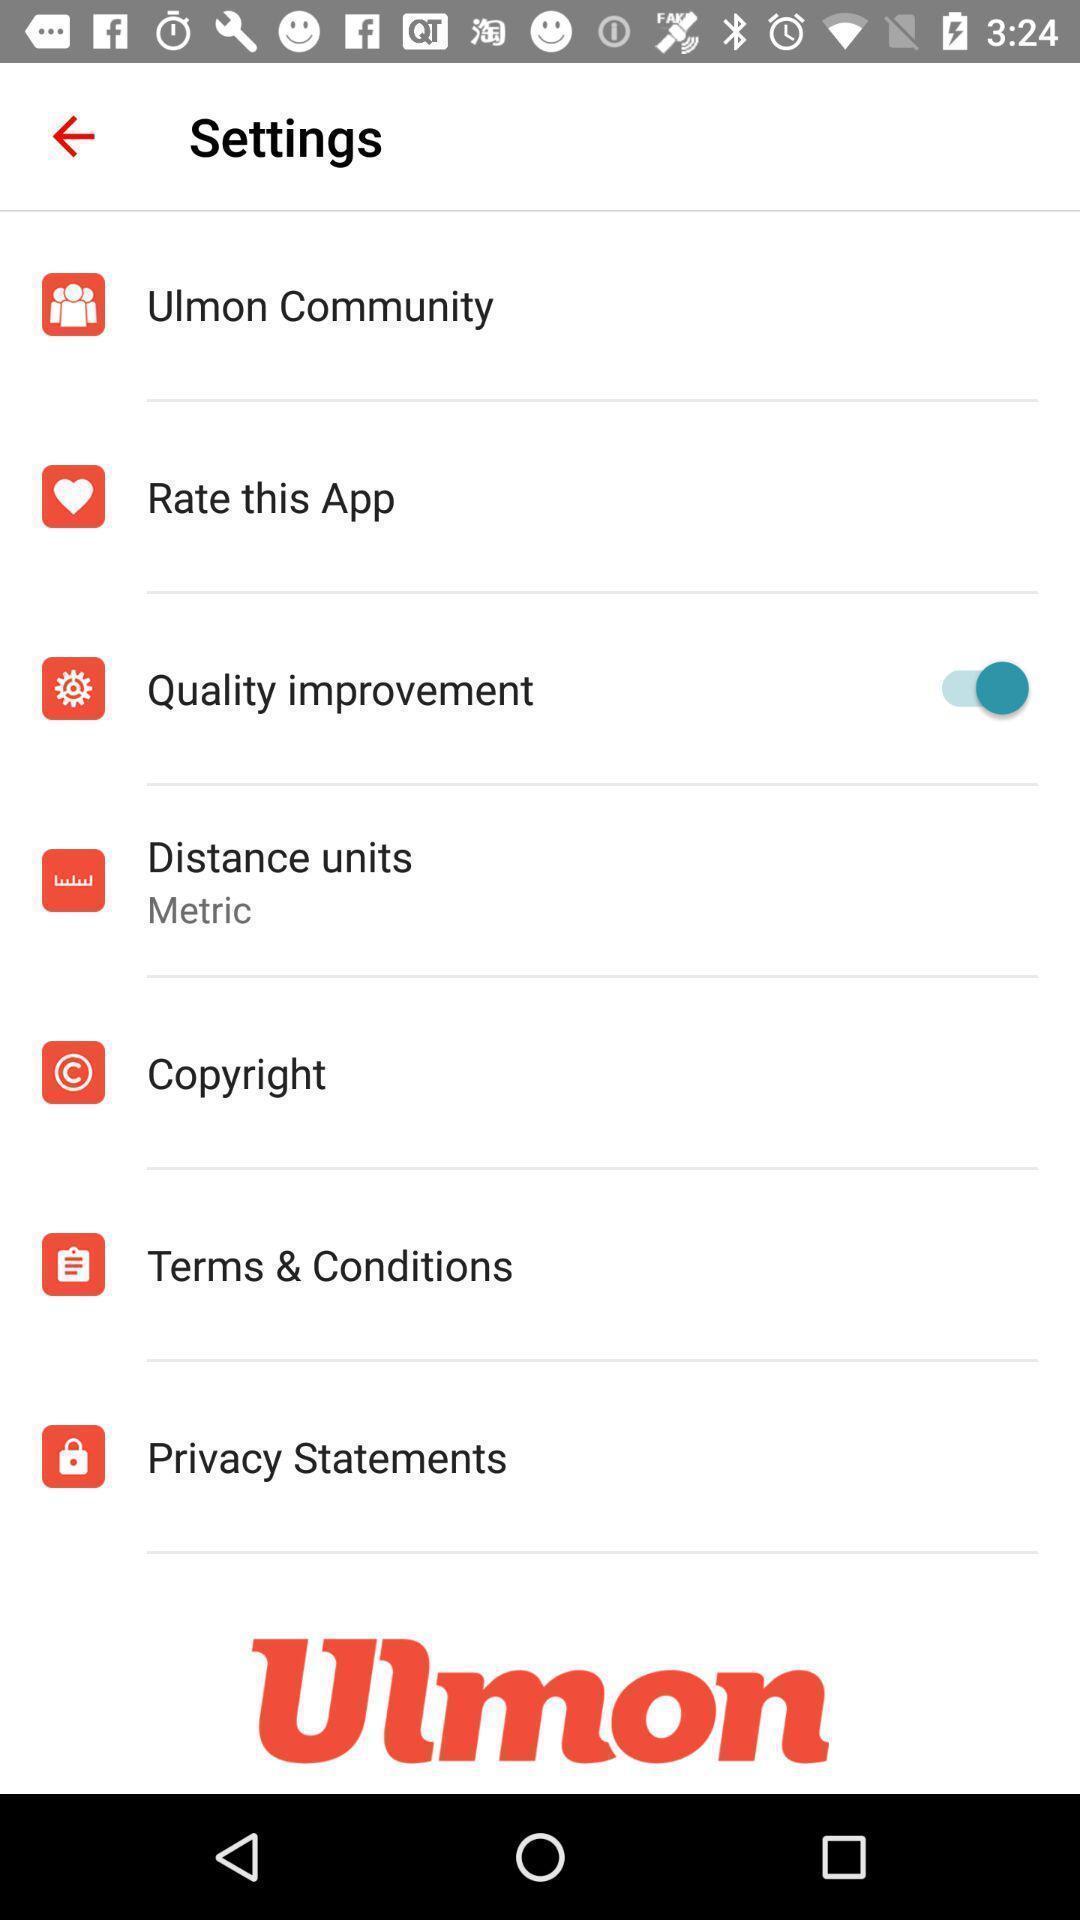Provide a detailed account of this screenshot. Settings page with several options. 